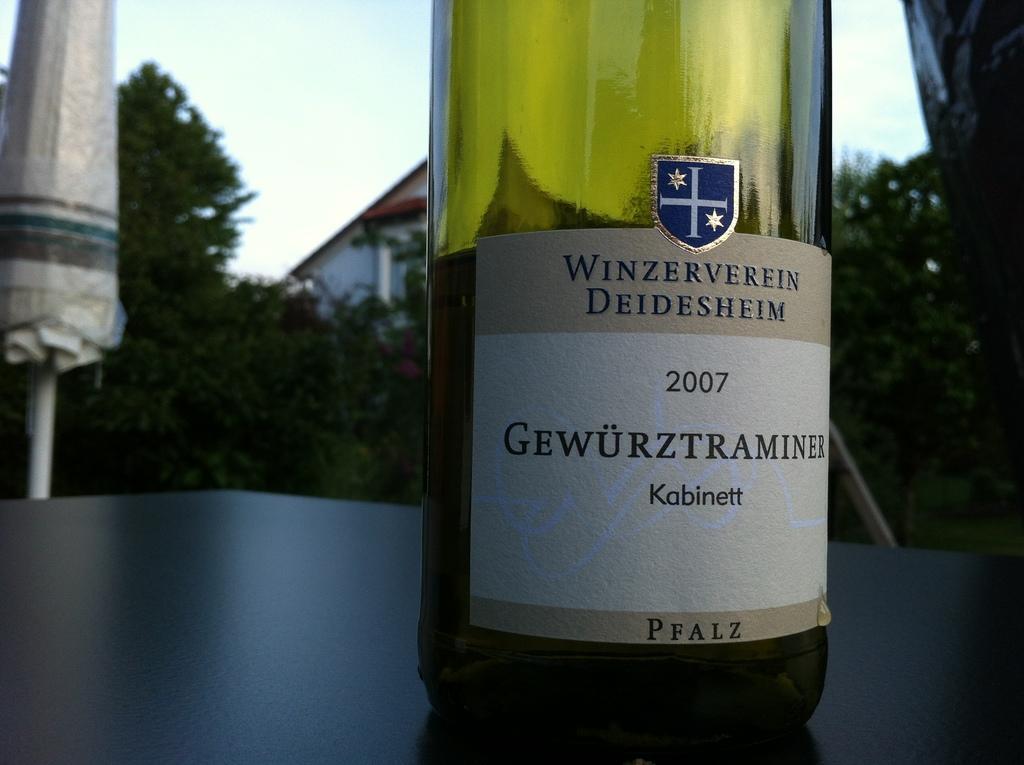Please provide a concise description of this image. In this image, a bottle is kept on the table. On both side in the middle, there are trees visible. On the top left and right, sky is there in blue color. Below that a house is visible. This image is taken during day time. 